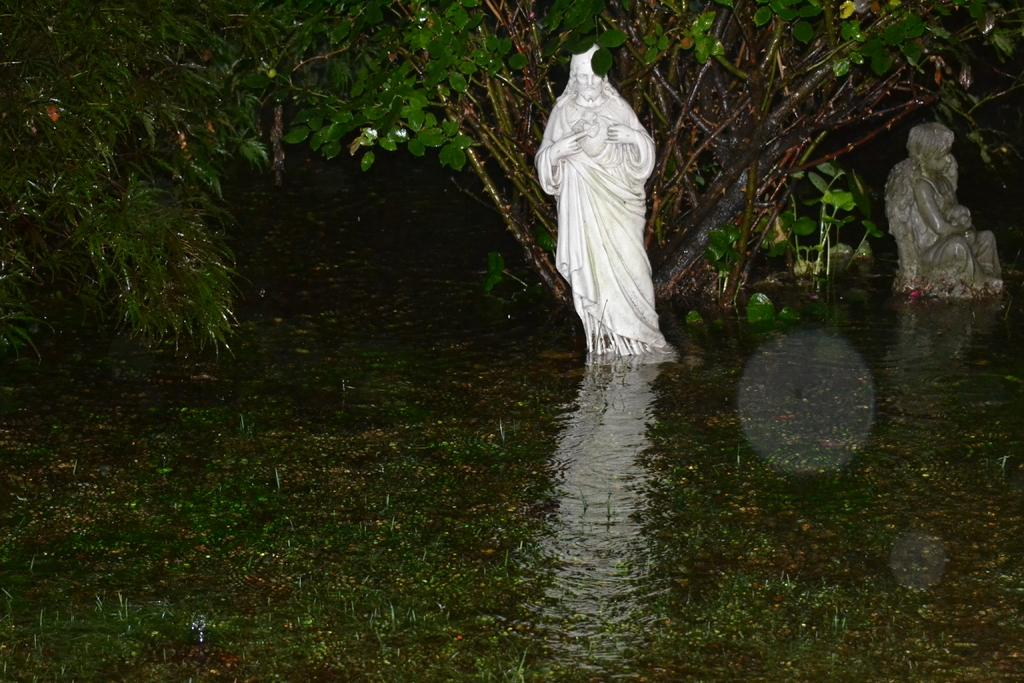What objects are present in the image? There are statues in the image. Where are the statues located? The statues are in the middle of a river. What other natural element is visible in the image? There is a tree in the image. What type of fog can be seen surrounding the statues in the image? There is no fog present in the image; the statues are in the middle of a river with a visible tree. Can you tell me how many caves are visible in the image? There are no caves present in the image; it features statues in a river with a tree. 